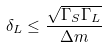<formula> <loc_0><loc_0><loc_500><loc_500>\delta _ { L } \leq \frac { \sqrt { \Gamma _ { S } \Gamma _ { L } } } { \Delta m }</formula> 